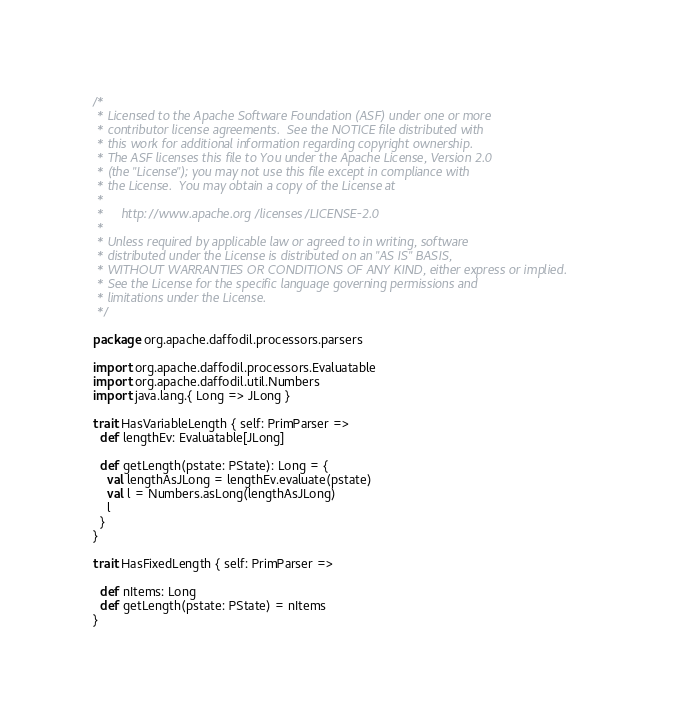<code> <loc_0><loc_0><loc_500><loc_500><_Scala_>/*
 * Licensed to the Apache Software Foundation (ASF) under one or more
 * contributor license agreements.  See the NOTICE file distributed with
 * this work for additional information regarding copyright ownership.
 * The ASF licenses this file to You under the Apache License, Version 2.0
 * (the "License"); you may not use this file except in compliance with
 * the License.  You may obtain a copy of the License at
 *
 *     http://www.apache.org/licenses/LICENSE-2.0
 *
 * Unless required by applicable law or agreed to in writing, software
 * distributed under the License is distributed on an "AS IS" BASIS,
 * WITHOUT WARRANTIES OR CONDITIONS OF ANY KIND, either express or implied.
 * See the License for the specific language governing permissions and
 * limitations under the License.
 */

package org.apache.daffodil.processors.parsers

import org.apache.daffodil.processors.Evaluatable
import org.apache.daffodil.util.Numbers
import java.lang.{ Long => JLong }

trait HasVariableLength { self: PrimParser =>
  def lengthEv: Evaluatable[JLong]

  def getLength(pstate: PState): Long = {
    val lengthAsJLong = lengthEv.evaluate(pstate)
    val l = Numbers.asLong(lengthAsJLong)
    l
  }
}

trait HasFixedLength { self: PrimParser =>

  def nItems: Long
  def getLength(pstate: PState) = nItems
}
</code> 